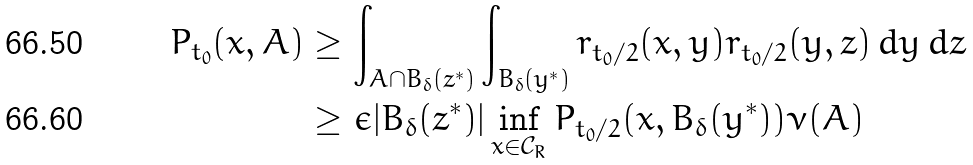Convert formula to latex. <formula><loc_0><loc_0><loc_500><loc_500>P _ { t _ { 0 } } ( x , A ) & \geq \int _ { A \cap B _ { \delta } ( z ^ { * } ) } \int _ { B _ { \delta } ( y ^ { * } ) } r _ { t _ { 0 } / 2 } ( x , y ) r _ { t _ { 0 } / 2 } ( y , z ) \, d y \, d z \\ & \geq \epsilon | B _ { \delta } ( z ^ { * } ) | \inf _ { x \in \mathcal { C } _ { R } } P _ { t _ { 0 } / 2 } ( x , B _ { \delta } ( y ^ { * } ) ) \nu ( A )</formula> 